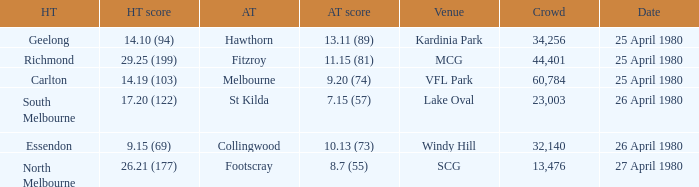What wa the date of the North Melbourne home game? 27 April 1980. 